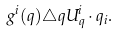<formula> <loc_0><loc_0><loc_500><loc_500>g ^ { i } ( q ) \triangle q U ^ { i } _ { q } \cdot q _ { i } .</formula> 